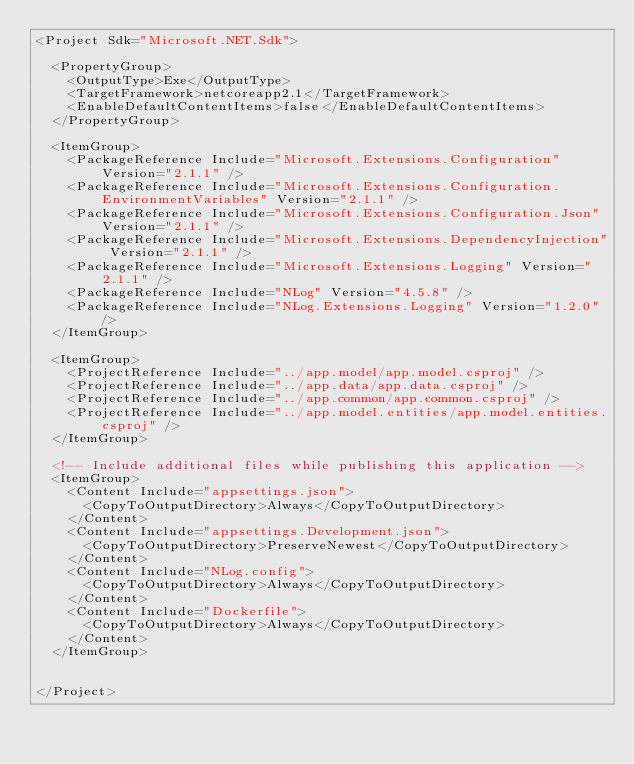Convert code to text. <code><loc_0><loc_0><loc_500><loc_500><_XML_><Project Sdk="Microsoft.NET.Sdk">

  <PropertyGroup>
    <OutputType>Exe</OutputType>
    <TargetFramework>netcoreapp2.1</TargetFramework>
    <EnableDefaultContentItems>false</EnableDefaultContentItems>
  </PropertyGroup>

  <ItemGroup>
    <PackageReference Include="Microsoft.Extensions.Configuration" Version="2.1.1" />
    <PackageReference Include="Microsoft.Extensions.Configuration.EnvironmentVariables" Version="2.1.1" />
    <PackageReference Include="Microsoft.Extensions.Configuration.Json" Version="2.1.1" />
    <PackageReference Include="Microsoft.Extensions.DependencyInjection" Version="2.1.1" />
    <PackageReference Include="Microsoft.Extensions.Logging" Version="2.1.1" />
    <PackageReference Include="NLog" Version="4.5.8" />
    <PackageReference Include="NLog.Extensions.Logging" Version="1.2.0" />
  </ItemGroup> 
  
  <ItemGroup>
    <ProjectReference Include="../app.model/app.model.csproj" />
    <ProjectReference Include="../app.data/app.data.csproj" />
    <ProjectReference Include="../app.common/app.common.csproj" />    
    <ProjectReference Include="../app.model.entities/app.model.entities.csproj" />
  </ItemGroup> 

  <!-- Include additional files while publishing this application -->
  <ItemGroup>
    <Content Include="appsettings.json">
      <CopyToOutputDirectory>Always</CopyToOutputDirectory>
    </Content>
    <Content Include="appsettings.Development.json">
      <CopyToOutputDirectory>PreserveNewest</CopyToOutputDirectory>
    </Content>
    <Content Include="NLog.config">
      <CopyToOutputDirectory>Always</CopyToOutputDirectory>
    </Content>        
    <Content Include="Dockerfile">
      <CopyToOutputDirectory>Always</CopyToOutputDirectory>
    </Content>    
  </ItemGroup>

  
</Project>
</code> 